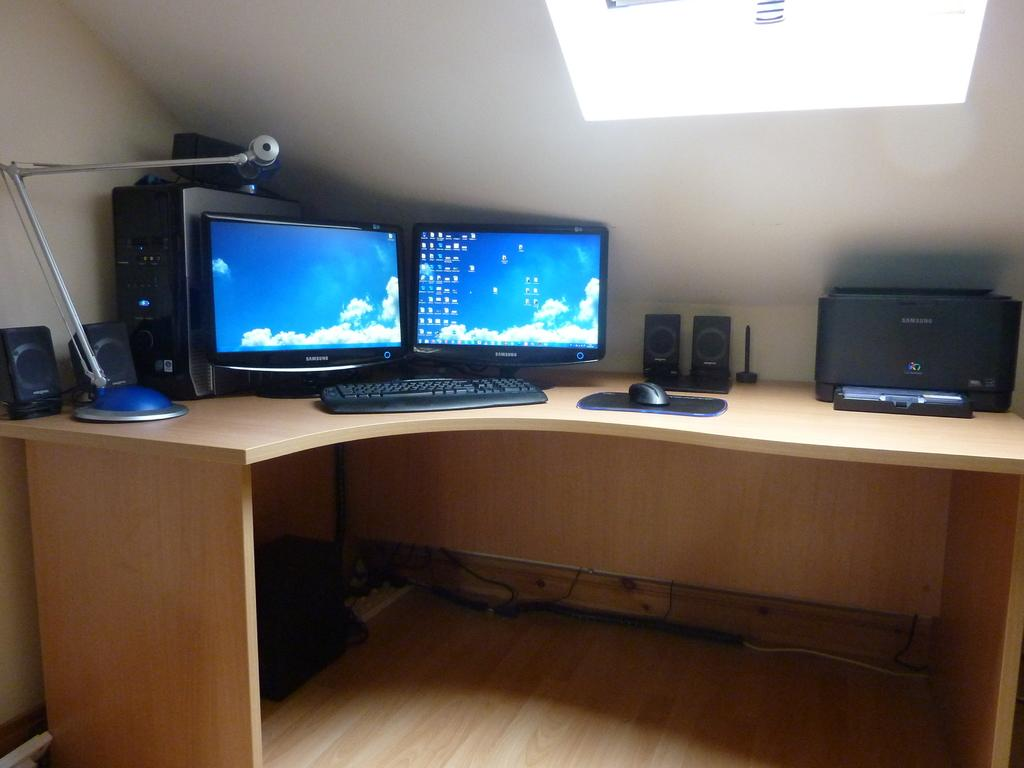What type of furniture is present in the image? There is a table in the image. What electronic devices are placed on the table? Two monitors, a keyboard, a CPU, two speakers, a mouse, a printer, and a lamp are on the table. Can you describe the arrangement of the items on the table? The items are arranged on the table in a way that suggests a workspace or computer setup. What type of sand can be seen at the seashore in the image? There is no seashore or sand present in the image; it features a table with electronic devices and other items. 